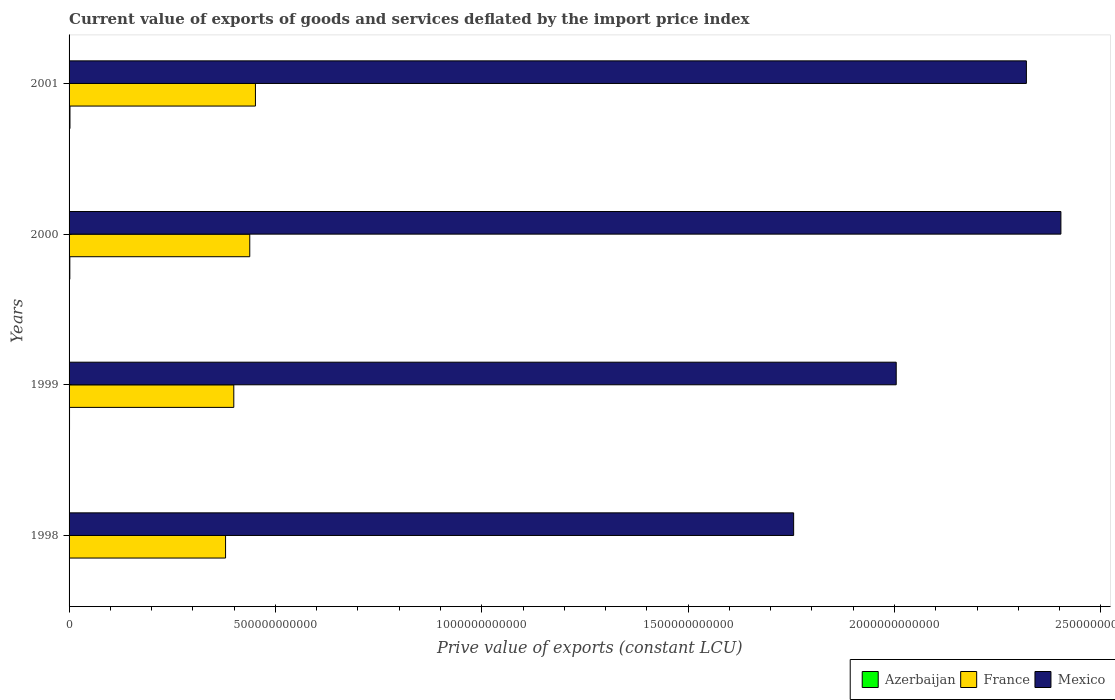How many different coloured bars are there?
Offer a very short reply. 3. Are the number of bars per tick equal to the number of legend labels?
Provide a short and direct response. Yes. Are the number of bars on each tick of the Y-axis equal?
Ensure brevity in your answer.  Yes. How many bars are there on the 2nd tick from the top?
Your response must be concise. 3. How many bars are there on the 3rd tick from the bottom?
Ensure brevity in your answer.  3. What is the label of the 3rd group of bars from the top?
Offer a terse response. 1999. What is the prive value of exports in Mexico in 1999?
Give a very brief answer. 2.00e+12. Across all years, what is the maximum prive value of exports in Azerbaijan?
Provide a succinct answer. 2.19e+09. Across all years, what is the minimum prive value of exports in France?
Offer a very short reply. 3.79e+11. What is the total prive value of exports in Azerbaijan in the graph?
Provide a succinct answer. 6.04e+09. What is the difference between the prive value of exports in Mexico in 1999 and that in 2000?
Give a very brief answer. -3.99e+11. What is the difference between the prive value of exports in France in 1998 and the prive value of exports in Azerbaijan in 1999?
Give a very brief answer. 3.78e+11. What is the average prive value of exports in Mexico per year?
Provide a short and direct response. 2.12e+12. In the year 2000, what is the difference between the prive value of exports in Azerbaijan and prive value of exports in Mexico?
Offer a terse response. -2.40e+12. What is the ratio of the prive value of exports in Azerbaijan in 1998 to that in 1999?
Your answer should be very brief. 0.79. What is the difference between the highest and the second highest prive value of exports in France?
Offer a terse response. 1.37e+1. What is the difference between the highest and the lowest prive value of exports in Mexico?
Offer a terse response. 6.48e+11. In how many years, is the prive value of exports in Mexico greater than the average prive value of exports in Mexico taken over all years?
Your answer should be very brief. 2. Is the sum of the prive value of exports in Azerbaijan in 1998 and 2000 greater than the maximum prive value of exports in France across all years?
Provide a short and direct response. No. What does the 3rd bar from the top in 2000 represents?
Offer a very short reply. Azerbaijan. What does the 2nd bar from the bottom in 2000 represents?
Your answer should be compact. France. Is it the case that in every year, the sum of the prive value of exports in Azerbaijan and prive value of exports in Mexico is greater than the prive value of exports in France?
Provide a succinct answer. Yes. How many years are there in the graph?
Your response must be concise. 4. What is the difference between two consecutive major ticks on the X-axis?
Offer a very short reply. 5.00e+11. Where does the legend appear in the graph?
Make the answer very short. Bottom right. How are the legend labels stacked?
Give a very brief answer. Horizontal. What is the title of the graph?
Give a very brief answer. Current value of exports of goods and services deflated by the import price index. What is the label or title of the X-axis?
Your answer should be very brief. Prive value of exports (constant LCU). What is the Prive value of exports (constant LCU) of Azerbaijan in 1998?
Ensure brevity in your answer.  8.82e+08. What is the Prive value of exports (constant LCU) of France in 1998?
Your answer should be compact. 3.79e+11. What is the Prive value of exports (constant LCU) of Mexico in 1998?
Make the answer very short. 1.76e+12. What is the Prive value of exports (constant LCU) of Azerbaijan in 1999?
Offer a very short reply. 1.12e+09. What is the Prive value of exports (constant LCU) in France in 1999?
Offer a very short reply. 3.99e+11. What is the Prive value of exports (constant LCU) of Mexico in 1999?
Provide a short and direct response. 2.00e+12. What is the Prive value of exports (constant LCU) in Azerbaijan in 2000?
Keep it short and to the point. 1.84e+09. What is the Prive value of exports (constant LCU) in France in 2000?
Your answer should be very brief. 4.38e+11. What is the Prive value of exports (constant LCU) of Mexico in 2000?
Give a very brief answer. 2.40e+12. What is the Prive value of exports (constant LCU) of Azerbaijan in 2001?
Your answer should be compact. 2.19e+09. What is the Prive value of exports (constant LCU) in France in 2001?
Offer a terse response. 4.52e+11. What is the Prive value of exports (constant LCU) in Mexico in 2001?
Offer a very short reply. 2.32e+12. Across all years, what is the maximum Prive value of exports (constant LCU) in Azerbaijan?
Your answer should be very brief. 2.19e+09. Across all years, what is the maximum Prive value of exports (constant LCU) in France?
Offer a very short reply. 4.52e+11. Across all years, what is the maximum Prive value of exports (constant LCU) in Mexico?
Provide a short and direct response. 2.40e+12. Across all years, what is the minimum Prive value of exports (constant LCU) of Azerbaijan?
Make the answer very short. 8.82e+08. Across all years, what is the minimum Prive value of exports (constant LCU) in France?
Ensure brevity in your answer.  3.79e+11. Across all years, what is the minimum Prive value of exports (constant LCU) of Mexico?
Offer a terse response. 1.76e+12. What is the total Prive value of exports (constant LCU) of Azerbaijan in the graph?
Make the answer very short. 6.04e+09. What is the total Prive value of exports (constant LCU) in France in the graph?
Your answer should be very brief. 1.67e+12. What is the total Prive value of exports (constant LCU) of Mexico in the graph?
Offer a terse response. 8.48e+12. What is the difference between the Prive value of exports (constant LCU) in Azerbaijan in 1998 and that in 1999?
Make the answer very short. -2.41e+08. What is the difference between the Prive value of exports (constant LCU) in France in 1998 and that in 1999?
Your response must be concise. -2.00e+1. What is the difference between the Prive value of exports (constant LCU) of Mexico in 1998 and that in 1999?
Offer a terse response. -2.49e+11. What is the difference between the Prive value of exports (constant LCU) of Azerbaijan in 1998 and that in 2000?
Your answer should be compact. -9.60e+08. What is the difference between the Prive value of exports (constant LCU) in France in 1998 and that in 2000?
Your response must be concise. -5.86e+1. What is the difference between the Prive value of exports (constant LCU) of Mexico in 1998 and that in 2000?
Provide a short and direct response. -6.48e+11. What is the difference between the Prive value of exports (constant LCU) of Azerbaijan in 1998 and that in 2001?
Offer a very short reply. -1.31e+09. What is the difference between the Prive value of exports (constant LCU) of France in 1998 and that in 2001?
Offer a terse response. -7.24e+1. What is the difference between the Prive value of exports (constant LCU) of Mexico in 1998 and that in 2001?
Keep it short and to the point. -5.64e+11. What is the difference between the Prive value of exports (constant LCU) of Azerbaijan in 1999 and that in 2000?
Provide a succinct answer. -7.19e+08. What is the difference between the Prive value of exports (constant LCU) of France in 1999 and that in 2000?
Make the answer very short. -3.87e+1. What is the difference between the Prive value of exports (constant LCU) of Mexico in 1999 and that in 2000?
Your answer should be very brief. -3.99e+11. What is the difference between the Prive value of exports (constant LCU) of Azerbaijan in 1999 and that in 2001?
Make the answer very short. -1.07e+09. What is the difference between the Prive value of exports (constant LCU) in France in 1999 and that in 2001?
Your answer should be compact. -5.24e+1. What is the difference between the Prive value of exports (constant LCU) in Mexico in 1999 and that in 2001?
Your answer should be very brief. -3.15e+11. What is the difference between the Prive value of exports (constant LCU) of Azerbaijan in 2000 and that in 2001?
Offer a terse response. -3.49e+08. What is the difference between the Prive value of exports (constant LCU) of France in 2000 and that in 2001?
Give a very brief answer. -1.37e+1. What is the difference between the Prive value of exports (constant LCU) of Mexico in 2000 and that in 2001?
Offer a terse response. 8.36e+1. What is the difference between the Prive value of exports (constant LCU) in Azerbaijan in 1998 and the Prive value of exports (constant LCU) in France in 1999?
Offer a very short reply. -3.98e+11. What is the difference between the Prive value of exports (constant LCU) of Azerbaijan in 1998 and the Prive value of exports (constant LCU) of Mexico in 1999?
Provide a short and direct response. -2.00e+12. What is the difference between the Prive value of exports (constant LCU) in France in 1998 and the Prive value of exports (constant LCU) in Mexico in 1999?
Provide a short and direct response. -1.63e+12. What is the difference between the Prive value of exports (constant LCU) of Azerbaijan in 1998 and the Prive value of exports (constant LCU) of France in 2000?
Offer a terse response. -4.37e+11. What is the difference between the Prive value of exports (constant LCU) in Azerbaijan in 1998 and the Prive value of exports (constant LCU) in Mexico in 2000?
Your response must be concise. -2.40e+12. What is the difference between the Prive value of exports (constant LCU) in France in 1998 and the Prive value of exports (constant LCU) in Mexico in 2000?
Provide a succinct answer. -2.02e+12. What is the difference between the Prive value of exports (constant LCU) of Azerbaijan in 1998 and the Prive value of exports (constant LCU) of France in 2001?
Keep it short and to the point. -4.51e+11. What is the difference between the Prive value of exports (constant LCU) in Azerbaijan in 1998 and the Prive value of exports (constant LCU) in Mexico in 2001?
Ensure brevity in your answer.  -2.32e+12. What is the difference between the Prive value of exports (constant LCU) of France in 1998 and the Prive value of exports (constant LCU) of Mexico in 2001?
Offer a very short reply. -1.94e+12. What is the difference between the Prive value of exports (constant LCU) of Azerbaijan in 1999 and the Prive value of exports (constant LCU) of France in 2000?
Your response must be concise. -4.37e+11. What is the difference between the Prive value of exports (constant LCU) in Azerbaijan in 1999 and the Prive value of exports (constant LCU) in Mexico in 2000?
Provide a short and direct response. -2.40e+12. What is the difference between the Prive value of exports (constant LCU) in France in 1999 and the Prive value of exports (constant LCU) in Mexico in 2000?
Keep it short and to the point. -2.00e+12. What is the difference between the Prive value of exports (constant LCU) of Azerbaijan in 1999 and the Prive value of exports (constant LCU) of France in 2001?
Your answer should be very brief. -4.50e+11. What is the difference between the Prive value of exports (constant LCU) in Azerbaijan in 1999 and the Prive value of exports (constant LCU) in Mexico in 2001?
Provide a short and direct response. -2.32e+12. What is the difference between the Prive value of exports (constant LCU) of France in 1999 and the Prive value of exports (constant LCU) of Mexico in 2001?
Provide a succinct answer. -1.92e+12. What is the difference between the Prive value of exports (constant LCU) of Azerbaijan in 2000 and the Prive value of exports (constant LCU) of France in 2001?
Your answer should be very brief. -4.50e+11. What is the difference between the Prive value of exports (constant LCU) of Azerbaijan in 2000 and the Prive value of exports (constant LCU) of Mexico in 2001?
Offer a terse response. -2.32e+12. What is the difference between the Prive value of exports (constant LCU) of France in 2000 and the Prive value of exports (constant LCU) of Mexico in 2001?
Offer a terse response. -1.88e+12. What is the average Prive value of exports (constant LCU) of Azerbaijan per year?
Keep it short and to the point. 1.51e+09. What is the average Prive value of exports (constant LCU) in France per year?
Provide a succinct answer. 4.17e+11. What is the average Prive value of exports (constant LCU) of Mexico per year?
Your answer should be very brief. 2.12e+12. In the year 1998, what is the difference between the Prive value of exports (constant LCU) in Azerbaijan and Prive value of exports (constant LCU) in France?
Make the answer very short. -3.78e+11. In the year 1998, what is the difference between the Prive value of exports (constant LCU) in Azerbaijan and Prive value of exports (constant LCU) in Mexico?
Provide a short and direct response. -1.75e+12. In the year 1998, what is the difference between the Prive value of exports (constant LCU) in France and Prive value of exports (constant LCU) in Mexico?
Provide a succinct answer. -1.38e+12. In the year 1999, what is the difference between the Prive value of exports (constant LCU) in Azerbaijan and Prive value of exports (constant LCU) in France?
Keep it short and to the point. -3.98e+11. In the year 1999, what is the difference between the Prive value of exports (constant LCU) in Azerbaijan and Prive value of exports (constant LCU) in Mexico?
Your answer should be very brief. -2.00e+12. In the year 1999, what is the difference between the Prive value of exports (constant LCU) of France and Prive value of exports (constant LCU) of Mexico?
Your answer should be compact. -1.61e+12. In the year 2000, what is the difference between the Prive value of exports (constant LCU) in Azerbaijan and Prive value of exports (constant LCU) in France?
Your response must be concise. -4.36e+11. In the year 2000, what is the difference between the Prive value of exports (constant LCU) of Azerbaijan and Prive value of exports (constant LCU) of Mexico?
Offer a very short reply. -2.40e+12. In the year 2000, what is the difference between the Prive value of exports (constant LCU) of France and Prive value of exports (constant LCU) of Mexico?
Your answer should be very brief. -1.97e+12. In the year 2001, what is the difference between the Prive value of exports (constant LCU) in Azerbaijan and Prive value of exports (constant LCU) in France?
Make the answer very short. -4.49e+11. In the year 2001, what is the difference between the Prive value of exports (constant LCU) in Azerbaijan and Prive value of exports (constant LCU) in Mexico?
Provide a short and direct response. -2.32e+12. In the year 2001, what is the difference between the Prive value of exports (constant LCU) of France and Prive value of exports (constant LCU) of Mexico?
Your response must be concise. -1.87e+12. What is the ratio of the Prive value of exports (constant LCU) in Azerbaijan in 1998 to that in 1999?
Your response must be concise. 0.79. What is the ratio of the Prive value of exports (constant LCU) of Mexico in 1998 to that in 1999?
Your answer should be compact. 0.88. What is the ratio of the Prive value of exports (constant LCU) of Azerbaijan in 1998 to that in 2000?
Ensure brevity in your answer.  0.48. What is the ratio of the Prive value of exports (constant LCU) in France in 1998 to that in 2000?
Your answer should be compact. 0.87. What is the ratio of the Prive value of exports (constant LCU) of Mexico in 1998 to that in 2000?
Offer a very short reply. 0.73. What is the ratio of the Prive value of exports (constant LCU) in Azerbaijan in 1998 to that in 2001?
Provide a short and direct response. 0.4. What is the ratio of the Prive value of exports (constant LCU) of France in 1998 to that in 2001?
Offer a very short reply. 0.84. What is the ratio of the Prive value of exports (constant LCU) in Mexico in 1998 to that in 2001?
Ensure brevity in your answer.  0.76. What is the ratio of the Prive value of exports (constant LCU) of Azerbaijan in 1999 to that in 2000?
Offer a very short reply. 0.61. What is the ratio of the Prive value of exports (constant LCU) in France in 1999 to that in 2000?
Your response must be concise. 0.91. What is the ratio of the Prive value of exports (constant LCU) of Mexico in 1999 to that in 2000?
Keep it short and to the point. 0.83. What is the ratio of the Prive value of exports (constant LCU) in Azerbaijan in 1999 to that in 2001?
Your answer should be very brief. 0.51. What is the ratio of the Prive value of exports (constant LCU) in France in 1999 to that in 2001?
Provide a short and direct response. 0.88. What is the ratio of the Prive value of exports (constant LCU) of Mexico in 1999 to that in 2001?
Your response must be concise. 0.86. What is the ratio of the Prive value of exports (constant LCU) of Azerbaijan in 2000 to that in 2001?
Offer a very short reply. 0.84. What is the ratio of the Prive value of exports (constant LCU) of France in 2000 to that in 2001?
Ensure brevity in your answer.  0.97. What is the ratio of the Prive value of exports (constant LCU) of Mexico in 2000 to that in 2001?
Your answer should be compact. 1.04. What is the difference between the highest and the second highest Prive value of exports (constant LCU) of Azerbaijan?
Your answer should be very brief. 3.49e+08. What is the difference between the highest and the second highest Prive value of exports (constant LCU) in France?
Your response must be concise. 1.37e+1. What is the difference between the highest and the second highest Prive value of exports (constant LCU) in Mexico?
Keep it short and to the point. 8.36e+1. What is the difference between the highest and the lowest Prive value of exports (constant LCU) in Azerbaijan?
Your answer should be very brief. 1.31e+09. What is the difference between the highest and the lowest Prive value of exports (constant LCU) in France?
Offer a very short reply. 7.24e+1. What is the difference between the highest and the lowest Prive value of exports (constant LCU) of Mexico?
Ensure brevity in your answer.  6.48e+11. 